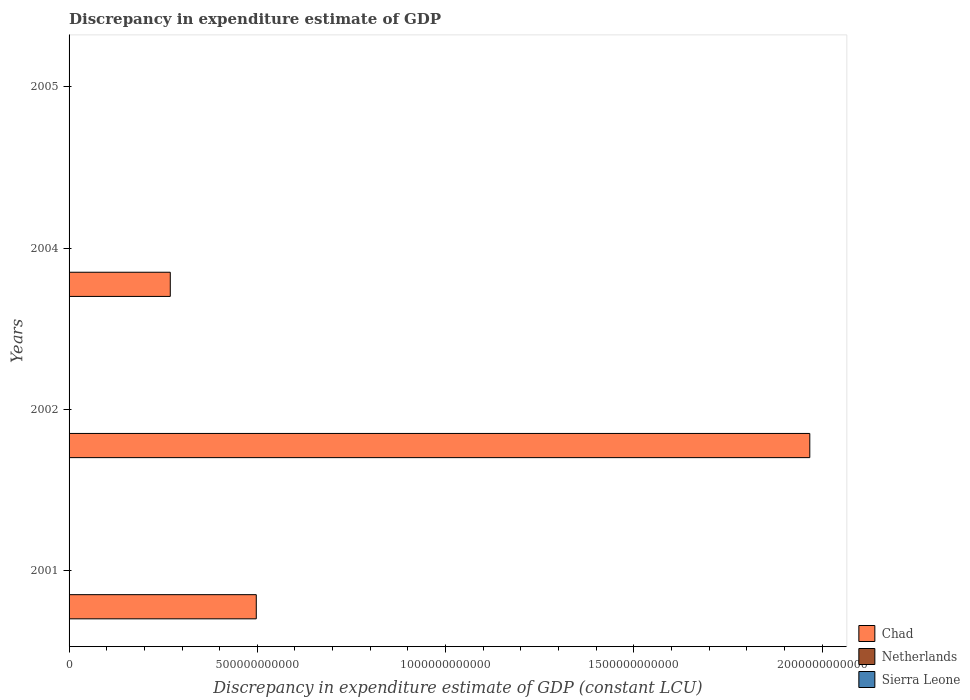How many different coloured bars are there?
Provide a short and direct response. 3. How many groups of bars are there?
Your answer should be compact. 4. Are the number of bars on each tick of the Y-axis equal?
Make the answer very short. No. How many bars are there on the 4th tick from the top?
Give a very brief answer. 2. What is the label of the 3rd group of bars from the top?
Offer a very short reply. 2002. Across all years, what is the minimum discrepancy in expenditure estimate of GDP in Netherlands?
Provide a short and direct response. 5.77e+07. In which year was the discrepancy in expenditure estimate of GDP in Sierra Leone maximum?
Ensure brevity in your answer.  2002. What is the total discrepancy in expenditure estimate of GDP in Netherlands in the graph?
Offer a terse response. 3.32e+08. What is the difference between the discrepancy in expenditure estimate of GDP in Netherlands in 2001 and that in 2005?
Give a very brief answer. -2.06e+07. What is the difference between the discrepancy in expenditure estimate of GDP in Netherlands in 2005 and the discrepancy in expenditure estimate of GDP in Sierra Leone in 2002?
Offer a very short reply. 8.44e+07. What is the average discrepancy in expenditure estimate of GDP in Netherlands per year?
Your answer should be very brief. 8.30e+07. In the year 2004, what is the difference between the discrepancy in expenditure estimate of GDP in Chad and discrepancy in expenditure estimate of GDP in Netherlands?
Keep it short and to the point. 2.69e+11. In how many years, is the discrepancy in expenditure estimate of GDP in Netherlands greater than 1100000000000 LCU?
Your answer should be compact. 0. What is the ratio of the discrepancy in expenditure estimate of GDP in Chad in 2001 to that in 2002?
Provide a short and direct response. 0.25. Is the discrepancy in expenditure estimate of GDP in Netherlands in 2002 less than that in 2004?
Provide a succinct answer. Yes. Is the difference between the discrepancy in expenditure estimate of GDP in Chad in 2001 and 2004 greater than the difference between the discrepancy in expenditure estimate of GDP in Netherlands in 2001 and 2004?
Offer a very short reply. Yes. What is the difference between the highest and the second highest discrepancy in expenditure estimate of GDP in Chad?
Provide a succinct answer. 1.47e+12. What is the difference between the highest and the lowest discrepancy in expenditure estimate of GDP in Chad?
Offer a terse response. 1.97e+12. Is the sum of the discrepancy in expenditure estimate of GDP in Netherlands in 2001 and 2005 greater than the maximum discrepancy in expenditure estimate of GDP in Sierra Leone across all years?
Your response must be concise. Yes. How many bars are there?
Your answer should be very brief. 10. Are all the bars in the graph horizontal?
Keep it short and to the point. Yes. What is the difference between two consecutive major ticks on the X-axis?
Ensure brevity in your answer.  5.00e+11. Does the graph contain any zero values?
Make the answer very short. Yes. Where does the legend appear in the graph?
Your response must be concise. Bottom right. What is the title of the graph?
Provide a succinct answer. Discrepancy in expenditure estimate of GDP. What is the label or title of the X-axis?
Provide a succinct answer. Discrepancy in expenditure estimate of GDP (constant LCU). What is the label or title of the Y-axis?
Your response must be concise. Years. What is the Discrepancy in expenditure estimate of GDP (constant LCU) of Chad in 2001?
Provide a succinct answer. 4.97e+11. What is the Discrepancy in expenditure estimate of GDP (constant LCU) in Netherlands in 2001?
Your answer should be very brief. 6.98e+07. What is the Discrepancy in expenditure estimate of GDP (constant LCU) in Chad in 2002?
Offer a very short reply. 1.97e+12. What is the Discrepancy in expenditure estimate of GDP (constant LCU) of Netherlands in 2002?
Your answer should be very brief. 5.77e+07. What is the Discrepancy in expenditure estimate of GDP (constant LCU) of Chad in 2004?
Give a very brief answer. 2.69e+11. What is the Discrepancy in expenditure estimate of GDP (constant LCU) in Netherlands in 2004?
Offer a very short reply. 1.14e+08. What is the Discrepancy in expenditure estimate of GDP (constant LCU) in Chad in 2005?
Offer a very short reply. 100. What is the Discrepancy in expenditure estimate of GDP (constant LCU) of Netherlands in 2005?
Your response must be concise. 9.04e+07. What is the Discrepancy in expenditure estimate of GDP (constant LCU) in Sierra Leone in 2005?
Give a very brief answer. 3.00e+06. Across all years, what is the maximum Discrepancy in expenditure estimate of GDP (constant LCU) of Chad?
Make the answer very short. 1.97e+12. Across all years, what is the maximum Discrepancy in expenditure estimate of GDP (constant LCU) of Netherlands?
Offer a very short reply. 1.14e+08. Across all years, what is the minimum Discrepancy in expenditure estimate of GDP (constant LCU) in Chad?
Provide a succinct answer. 100. Across all years, what is the minimum Discrepancy in expenditure estimate of GDP (constant LCU) of Netherlands?
Give a very brief answer. 5.77e+07. What is the total Discrepancy in expenditure estimate of GDP (constant LCU) in Chad in the graph?
Make the answer very short. 2.73e+12. What is the total Discrepancy in expenditure estimate of GDP (constant LCU) of Netherlands in the graph?
Give a very brief answer. 3.32e+08. What is the total Discrepancy in expenditure estimate of GDP (constant LCU) of Sierra Leone in the graph?
Your answer should be very brief. 9.00e+06. What is the difference between the Discrepancy in expenditure estimate of GDP (constant LCU) of Chad in 2001 and that in 2002?
Offer a very short reply. -1.47e+12. What is the difference between the Discrepancy in expenditure estimate of GDP (constant LCU) of Netherlands in 2001 and that in 2002?
Make the answer very short. 1.21e+07. What is the difference between the Discrepancy in expenditure estimate of GDP (constant LCU) in Chad in 2001 and that in 2004?
Make the answer very short. 2.28e+11. What is the difference between the Discrepancy in expenditure estimate of GDP (constant LCU) in Netherlands in 2001 and that in 2004?
Your response must be concise. -4.42e+07. What is the difference between the Discrepancy in expenditure estimate of GDP (constant LCU) in Chad in 2001 and that in 2005?
Keep it short and to the point. 4.97e+11. What is the difference between the Discrepancy in expenditure estimate of GDP (constant LCU) of Netherlands in 2001 and that in 2005?
Offer a terse response. -2.06e+07. What is the difference between the Discrepancy in expenditure estimate of GDP (constant LCU) in Chad in 2002 and that in 2004?
Provide a short and direct response. 1.70e+12. What is the difference between the Discrepancy in expenditure estimate of GDP (constant LCU) of Netherlands in 2002 and that in 2004?
Provide a short and direct response. -5.63e+07. What is the difference between the Discrepancy in expenditure estimate of GDP (constant LCU) in Chad in 2002 and that in 2005?
Provide a short and direct response. 1.97e+12. What is the difference between the Discrepancy in expenditure estimate of GDP (constant LCU) in Netherlands in 2002 and that in 2005?
Your answer should be compact. -3.27e+07. What is the difference between the Discrepancy in expenditure estimate of GDP (constant LCU) in Chad in 2004 and that in 2005?
Your answer should be compact. 2.69e+11. What is the difference between the Discrepancy in expenditure estimate of GDP (constant LCU) of Netherlands in 2004 and that in 2005?
Your answer should be compact. 2.36e+07. What is the difference between the Discrepancy in expenditure estimate of GDP (constant LCU) in Chad in 2001 and the Discrepancy in expenditure estimate of GDP (constant LCU) in Netherlands in 2002?
Your answer should be compact. 4.97e+11. What is the difference between the Discrepancy in expenditure estimate of GDP (constant LCU) in Chad in 2001 and the Discrepancy in expenditure estimate of GDP (constant LCU) in Sierra Leone in 2002?
Make the answer very short. 4.97e+11. What is the difference between the Discrepancy in expenditure estimate of GDP (constant LCU) in Netherlands in 2001 and the Discrepancy in expenditure estimate of GDP (constant LCU) in Sierra Leone in 2002?
Your answer should be compact. 6.38e+07. What is the difference between the Discrepancy in expenditure estimate of GDP (constant LCU) in Chad in 2001 and the Discrepancy in expenditure estimate of GDP (constant LCU) in Netherlands in 2004?
Your response must be concise. 4.97e+11. What is the difference between the Discrepancy in expenditure estimate of GDP (constant LCU) of Chad in 2001 and the Discrepancy in expenditure estimate of GDP (constant LCU) of Netherlands in 2005?
Provide a succinct answer. 4.97e+11. What is the difference between the Discrepancy in expenditure estimate of GDP (constant LCU) of Chad in 2001 and the Discrepancy in expenditure estimate of GDP (constant LCU) of Sierra Leone in 2005?
Your answer should be compact. 4.97e+11. What is the difference between the Discrepancy in expenditure estimate of GDP (constant LCU) of Netherlands in 2001 and the Discrepancy in expenditure estimate of GDP (constant LCU) of Sierra Leone in 2005?
Keep it short and to the point. 6.68e+07. What is the difference between the Discrepancy in expenditure estimate of GDP (constant LCU) of Chad in 2002 and the Discrepancy in expenditure estimate of GDP (constant LCU) of Netherlands in 2004?
Your answer should be compact. 1.97e+12. What is the difference between the Discrepancy in expenditure estimate of GDP (constant LCU) of Chad in 2002 and the Discrepancy in expenditure estimate of GDP (constant LCU) of Netherlands in 2005?
Make the answer very short. 1.97e+12. What is the difference between the Discrepancy in expenditure estimate of GDP (constant LCU) in Chad in 2002 and the Discrepancy in expenditure estimate of GDP (constant LCU) in Sierra Leone in 2005?
Make the answer very short. 1.97e+12. What is the difference between the Discrepancy in expenditure estimate of GDP (constant LCU) in Netherlands in 2002 and the Discrepancy in expenditure estimate of GDP (constant LCU) in Sierra Leone in 2005?
Provide a succinct answer. 5.47e+07. What is the difference between the Discrepancy in expenditure estimate of GDP (constant LCU) of Chad in 2004 and the Discrepancy in expenditure estimate of GDP (constant LCU) of Netherlands in 2005?
Give a very brief answer. 2.69e+11. What is the difference between the Discrepancy in expenditure estimate of GDP (constant LCU) of Chad in 2004 and the Discrepancy in expenditure estimate of GDP (constant LCU) of Sierra Leone in 2005?
Keep it short and to the point. 2.69e+11. What is the difference between the Discrepancy in expenditure estimate of GDP (constant LCU) in Netherlands in 2004 and the Discrepancy in expenditure estimate of GDP (constant LCU) in Sierra Leone in 2005?
Keep it short and to the point. 1.11e+08. What is the average Discrepancy in expenditure estimate of GDP (constant LCU) of Chad per year?
Give a very brief answer. 6.83e+11. What is the average Discrepancy in expenditure estimate of GDP (constant LCU) in Netherlands per year?
Give a very brief answer. 8.30e+07. What is the average Discrepancy in expenditure estimate of GDP (constant LCU) of Sierra Leone per year?
Offer a terse response. 2.25e+06. In the year 2001, what is the difference between the Discrepancy in expenditure estimate of GDP (constant LCU) in Chad and Discrepancy in expenditure estimate of GDP (constant LCU) in Netherlands?
Make the answer very short. 4.97e+11. In the year 2002, what is the difference between the Discrepancy in expenditure estimate of GDP (constant LCU) of Chad and Discrepancy in expenditure estimate of GDP (constant LCU) of Netherlands?
Give a very brief answer. 1.97e+12. In the year 2002, what is the difference between the Discrepancy in expenditure estimate of GDP (constant LCU) in Chad and Discrepancy in expenditure estimate of GDP (constant LCU) in Sierra Leone?
Ensure brevity in your answer.  1.97e+12. In the year 2002, what is the difference between the Discrepancy in expenditure estimate of GDP (constant LCU) of Netherlands and Discrepancy in expenditure estimate of GDP (constant LCU) of Sierra Leone?
Keep it short and to the point. 5.17e+07. In the year 2004, what is the difference between the Discrepancy in expenditure estimate of GDP (constant LCU) of Chad and Discrepancy in expenditure estimate of GDP (constant LCU) of Netherlands?
Provide a short and direct response. 2.69e+11. In the year 2005, what is the difference between the Discrepancy in expenditure estimate of GDP (constant LCU) in Chad and Discrepancy in expenditure estimate of GDP (constant LCU) in Netherlands?
Your answer should be compact. -9.04e+07. In the year 2005, what is the difference between the Discrepancy in expenditure estimate of GDP (constant LCU) in Chad and Discrepancy in expenditure estimate of GDP (constant LCU) in Sierra Leone?
Ensure brevity in your answer.  -3.00e+06. In the year 2005, what is the difference between the Discrepancy in expenditure estimate of GDP (constant LCU) in Netherlands and Discrepancy in expenditure estimate of GDP (constant LCU) in Sierra Leone?
Make the answer very short. 8.74e+07. What is the ratio of the Discrepancy in expenditure estimate of GDP (constant LCU) in Chad in 2001 to that in 2002?
Give a very brief answer. 0.25. What is the ratio of the Discrepancy in expenditure estimate of GDP (constant LCU) in Netherlands in 2001 to that in 2002?
Provide a short and direct response. 1.21. What is the ratio of the Discrepancy in expenditure estimate of GDP (constant LCU) of Chad in 2001 to that in 2004?
Keep it short and to the point. 1.85. What is the ratio of the Discrepancy in expenditure estimate of GDP (constant LCU) in Netherlands in 2001 to that in 2004?
Your answer should be compact. 0.61. What is the ratio of the Discrepancy in expenditure estimate of GDP (constant LCU) of Chad in 2001 to that in 2005?
Provide a short and direct response. 4.97e+09. What is the ratio of the Discrepancy in expenditure estimate of GDP (constant LCU) in Netherlands in 2001 to that in 2005?
Give a very brief answer. 0.77. What is the ratio of the Discrepancy in expenditure estimate of GDP (constant LCU) of Chad in 2002 to that in 2004?
Give a very brief answer. 7.32. What is the ratio of the Discrepancy in expenditure estimate of GDP (constant LCU) of Netherlands in 2002 to that in 2004?
Ensure brevity in your answer.  0.51. What is the ratio of the Discrepancy in expenditure estimate of GDP (constant LCU) in Chad in 2002 to that in 2005?
Ensure brevity in your answer.  1.97e+1. What is the ratio of the Discrepancy in expenditure estimate of GDP (constant LCU) of Netherlands in 2002 to that in 2005?
Ensure brevity in your answer.  0.64. What is the ratio of the Discrepancy in expenditure estimate of GDP (constant LCU) of Chad in 2004 to that in 2005?
Your response must be concise. 2.69e+09. What is the ratio of the Discrepancy in expenditure estimate of GDP (constant LCU) in Netherlands in 2004 to that in 2005?
Your answer should be compact. 1.26. What is the difference between the highest and the second highest Discrepancy in expenditure estimate of GDP (constant LCU) of Chad?
Offer a terse response. 1.47e+12. What is the difference between the highest and the second highest Discrepancy in expenditure estimate of GDP (constant LCU) of Netherlands?
Provide a succinct answer. 2.36e+07. What is the difference between the highest and the lowest Discrepancy in expenditure estimate of GDP (constant LCU) of Chad?
Your answer should be compact. 1.97e+12. What is the difference between the highest and the lowest Discrepancy in expenditure estimate of GDP (constant LCU) of Netherlands?
Your response must be concise. 5.63e+07. What is the difference between the highest and the lowest Discrepancy in expenditure estimate of GDP (constant LCU) of Sierra Leone?
Offer a terse response. 6.00e+06. 